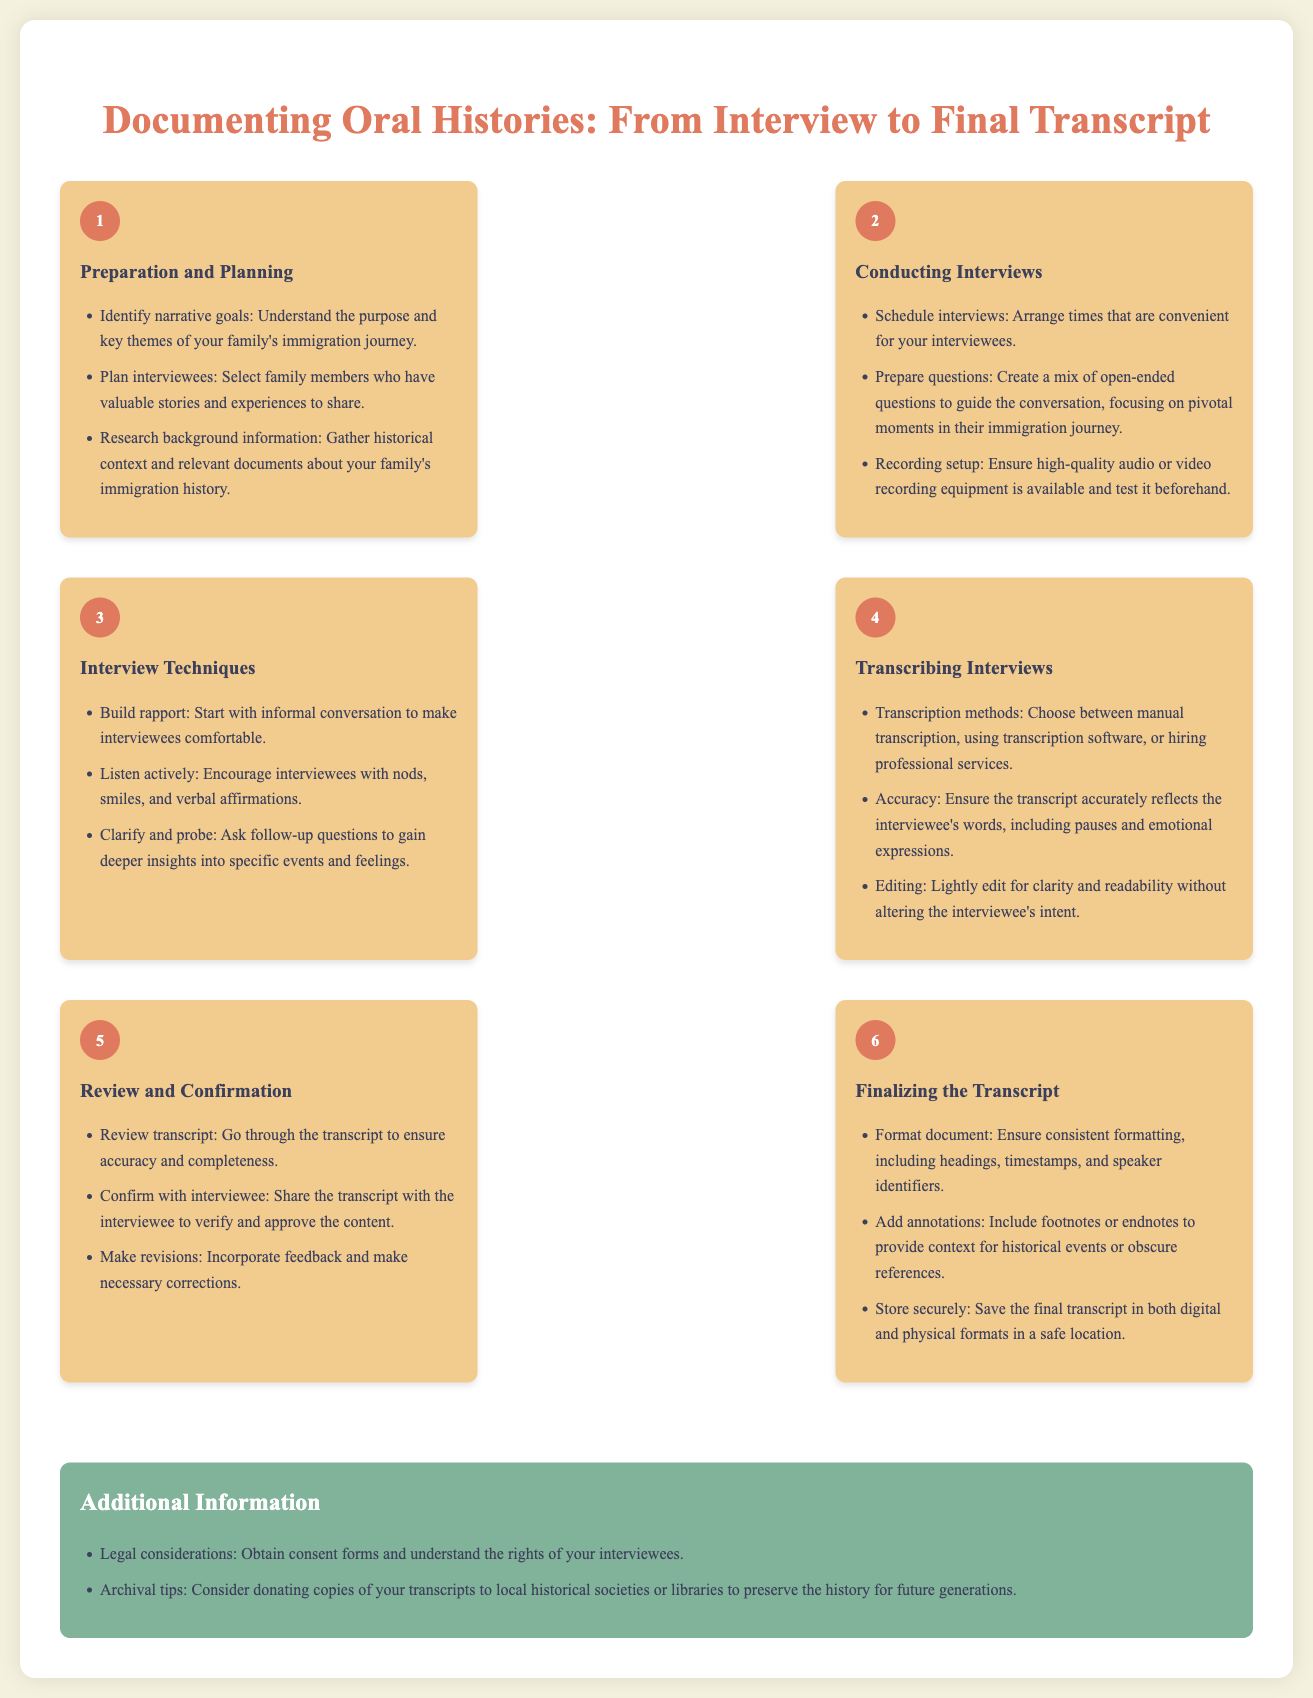What is the first step in documenting oral histories? The first step outlined in the infographic is "Preparation and Planning."
Answer: Preparation and Planning How many steps are there in the oral history documentation process? The infographic lists a total of six steps in the process of documenting oral histories.
Answer: Six What is one technique to make interviewees comfortable? The document suggests starting with informal conversation to build rapport.
Answer: Informal conversation Which transcription method is mentioned in the document? The document provides options such as manual transcription, transcription software, or hiring professional services.
Answer: Manual transcription, transcription software, hiring professional services What should you do after reviewing the transcript? The next step after reviewing is to confirm the content with the interviewee.
Answer: Confirm with interviewee What additional information is provided in the infographic? It discusses legal considerations and archival tips regarding the preservation of the transcripts.
Answer: Legal considerations, archival tips What color is used for the step numbers in the infographic? The step numbers are displayed in a background color of #e07a5f, which is described in the style section.
Answer: #e07a5f What is suggested regarding the final transcript's storage? The document advises saving the final transcript in both digital and physical formats.
Answer: Digital and physical formats 